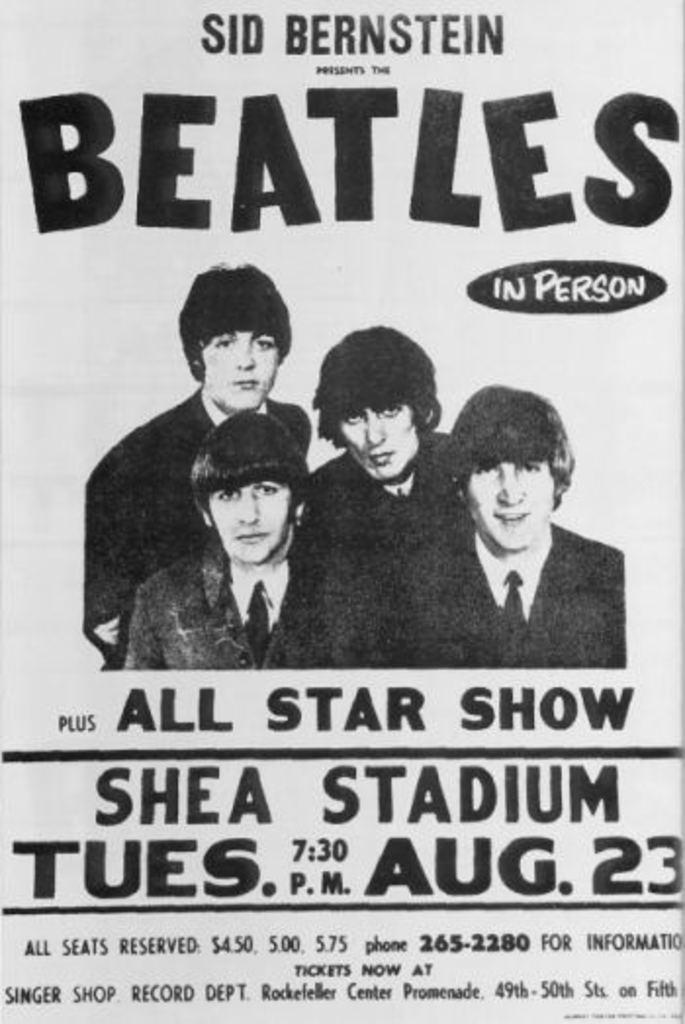What is featured in the image? There is a poster in the image. What is shown on the poster? The poster depicts four men. Are there any words or letters on the poster? Yes, there is text on the poster. How many sheep are visible on the poster? There are no sheep present on the poster; it features four men. What type of trousers are the men wearing on the poster? The provided facts do not mention the type of trousers the men are wearing, so we cannot answer this question. 